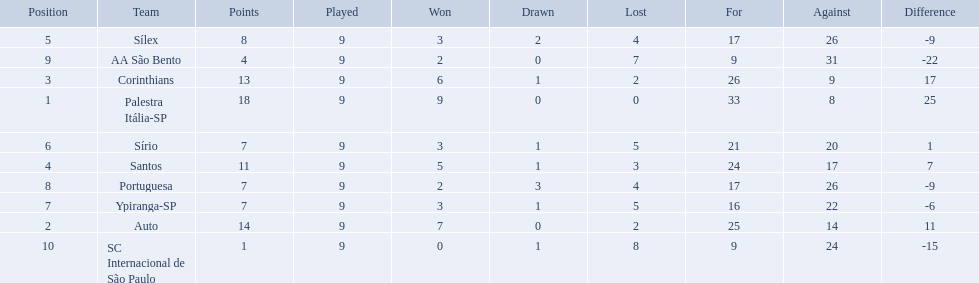How many games did each team play? 9, 9, 9, 9, 9, 9, 9, 9, 9, 9. Did any team score 13 points in the total games they played? 13. What is the name of that team? Corinthians. 